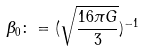Convert formula to latex. <formula><loc_0><loc_0><loc_500><loc_500>\beta _ { 0 } \colon = ( \sqrt { \frac { 1 6 \pi G } { 3 } } ) ^ { - 1 }</formula> 